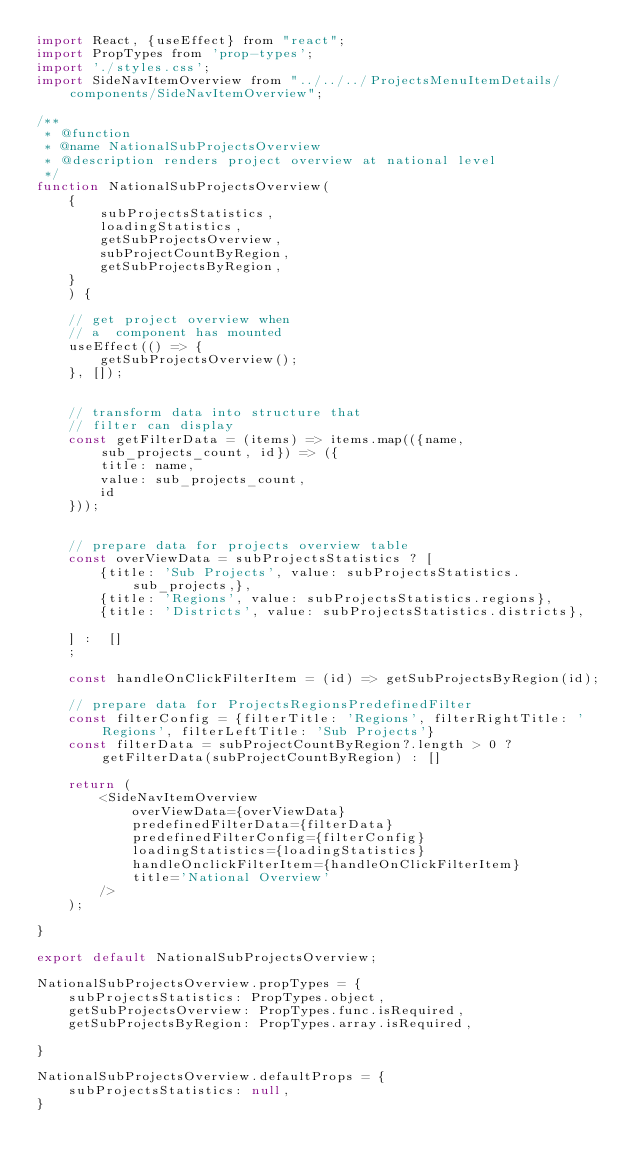<code> <loc_0><loc_0><loc_500><loc_500><_JavaScript_>import React, {useEffect} from "react";
import PropTypes from 'prop-types';
import './styles.css';
import SideNavItemOverview from "../../../ProjectsMenuItemDetails/components/SideNavItemOverview";

/**
 * @function
 * @name NationalSubProjectsOverview
 * @description renders project overview at national level
 */
function NationalSubProjectsOverview(
    {
        subProjectsStatistics,
        loadingStatistics,
        getSubProjectsOverview,
        subProjectCountByRegion,
        getSubProjectsByRegion,
    }
    ) {

    // get project overview when
    // a  component has mounted
    useEffect(() => {
        getSubProjectsOverview();
    }, []);


    // transform data into structure that
    // filter can display
    const getFilterData = (items) => items.map(({name, sub_projects_count, id}) => ({
        title: name,
        value: sub_projects_count,
        id
    }));


    // prepare data for projects overview table
    const overViewData = subProjectsStatistics ? [
        {title: 'Sub Projects', value: subProjectsStatistics.sub_projects,},
        {title: 'Regions', value: subProjectsStatistics.regions},
        {title: 'Districts', value: subProjectsStatistics.districts},

    ] :  []
    ;

    const handleOnClickFilterItem = (id) => getSubProjectsByRegion(id);

    // prepare data for ProjectsRegionsPredefinedFilter
    const filterConfig = {filterTitle: 'Regions', filterRightTitle: 'Regions', filterLeftTitle: 'Sub Projects'}
    const filterData = subProjectCountByRegion?.length > 0 ? getFilterData(subProjectCountByRegion) : []

    return (
        <SideNavItemOverview
            overViewData={overViewData}
            predefinedFilterData={filterData}
            predefinedFilterConfig={filterConfig}
            loadingStatistics={loadingStatistics}
            handleOnclickFilterItem={handleOnClickFilterItem}
            title='National Overview'
        />
    );

}

export default NationalSubProjectsOverview;

NationalSubProjectsOverview.propTypes = {
    subProjectsStatistics: PropTypes.object,
    getSubProjectsOverview: PropTypes.func.isRequired,
    getSubProjectsByRegion: PropTypes.array.isRequired,

}

NationalSubProjectsOverview.defaultProps = {
    subProjectsStatistics: null,
}
</code> 